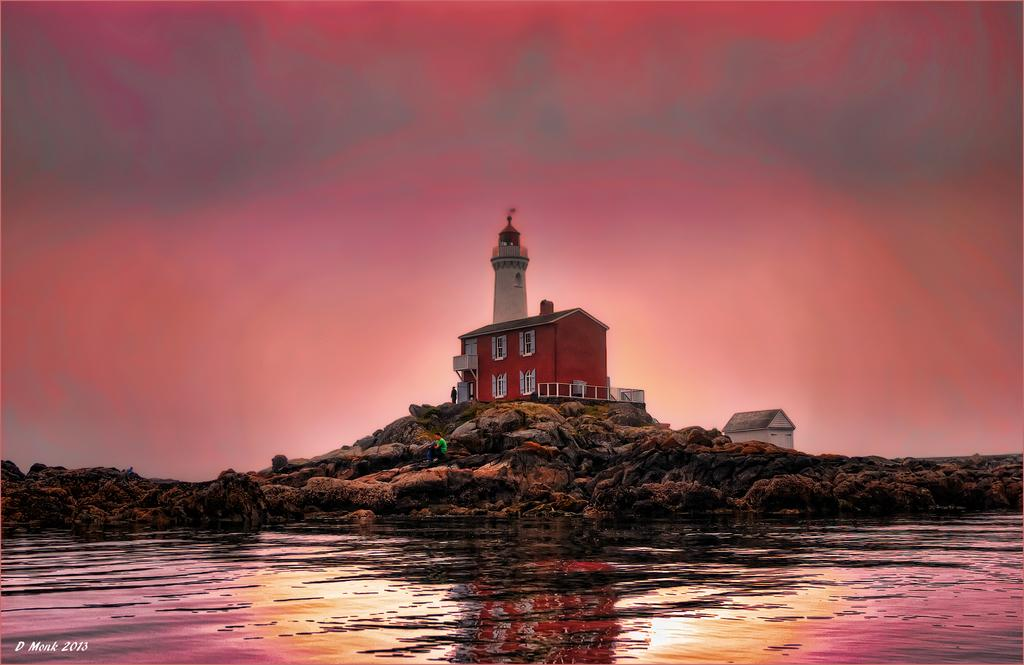What is the main structure in the center of the image? There is a lighthouse in the center of the image. What is the location of the building in the image? The building is on the rocks in the image. What can be seen at the bottom of the image? There is water at the bottom of the image. What is visible in the background of the image? The sky is visible in the background of the image. How many beads are scattered on the sand in the image? There is no sand or beads present in the image. How does the lighthouse move around in the image? The lighthouse does not move around in the image; it is stationary. 